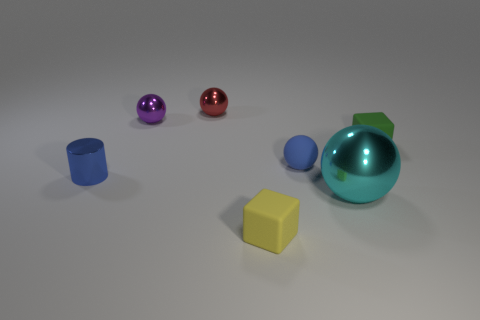Are there more small purple spheres than blue metal cubes?
Make the answer very short. Yes. There is a sphere that is in front of the purple metal sphere and behind the tiny blue shiny cylinder; how big is it?
Ensure brevity in your answer.  Small. There is a cylinder that is the same color as the small matte sphere; what is its material?
Your response must be concise. Metal. Are there the same number of objects in front of the red ball and blue cylinders?
Ensure brevity in your answer.  No. Does the red sphere have the same size as the yellow thing?
Provide a short and direct response. Yes. What color is the thing that is both on the left side of the big metal thing and in front of the metallic cylinder?
Offer a very short reply. Yellow. There is a small ball to the right of the red object behind the tiny blue rubber sphere; what is it made of?
Offer a very short reply. Rubber. The blue thing that is the same shape as the large cyan object is what size?
Keep it short and to the point. Small. There is a small block to the left of the blue matte thing; is it the same color as the big shiny thing?
Make the answer very short. No. Is the number of small blue rubber objects less than the number of balls?
Ensure brevity in your answer.  Yes. 